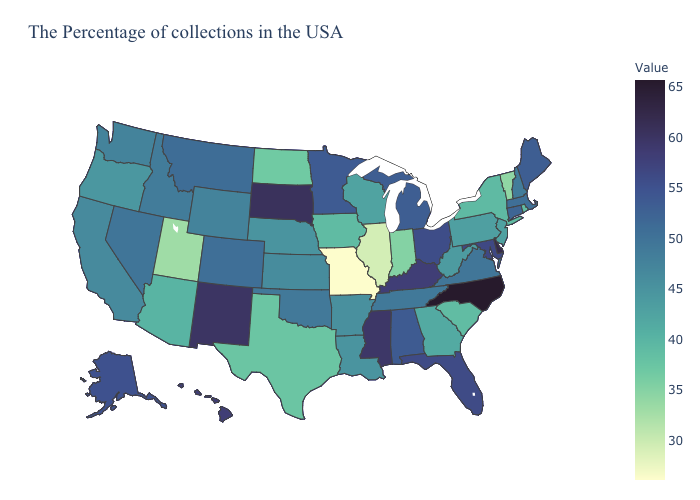Does Washington have the lowest value in the West?
Keep it brief. No. Does New Hampshire have a lower value than North Dakota?
Answer briefly. No. Which states have the lowest value in the Northeast?
Give a very brief answer. Vermont. Among the states that border New Hampshire , which have the lowest value?
Keep it brief. Vermont. Which states hav the highest value in the West?
Short answer required. New Mexico. Does the map have missing data?
Short answer required. No. 